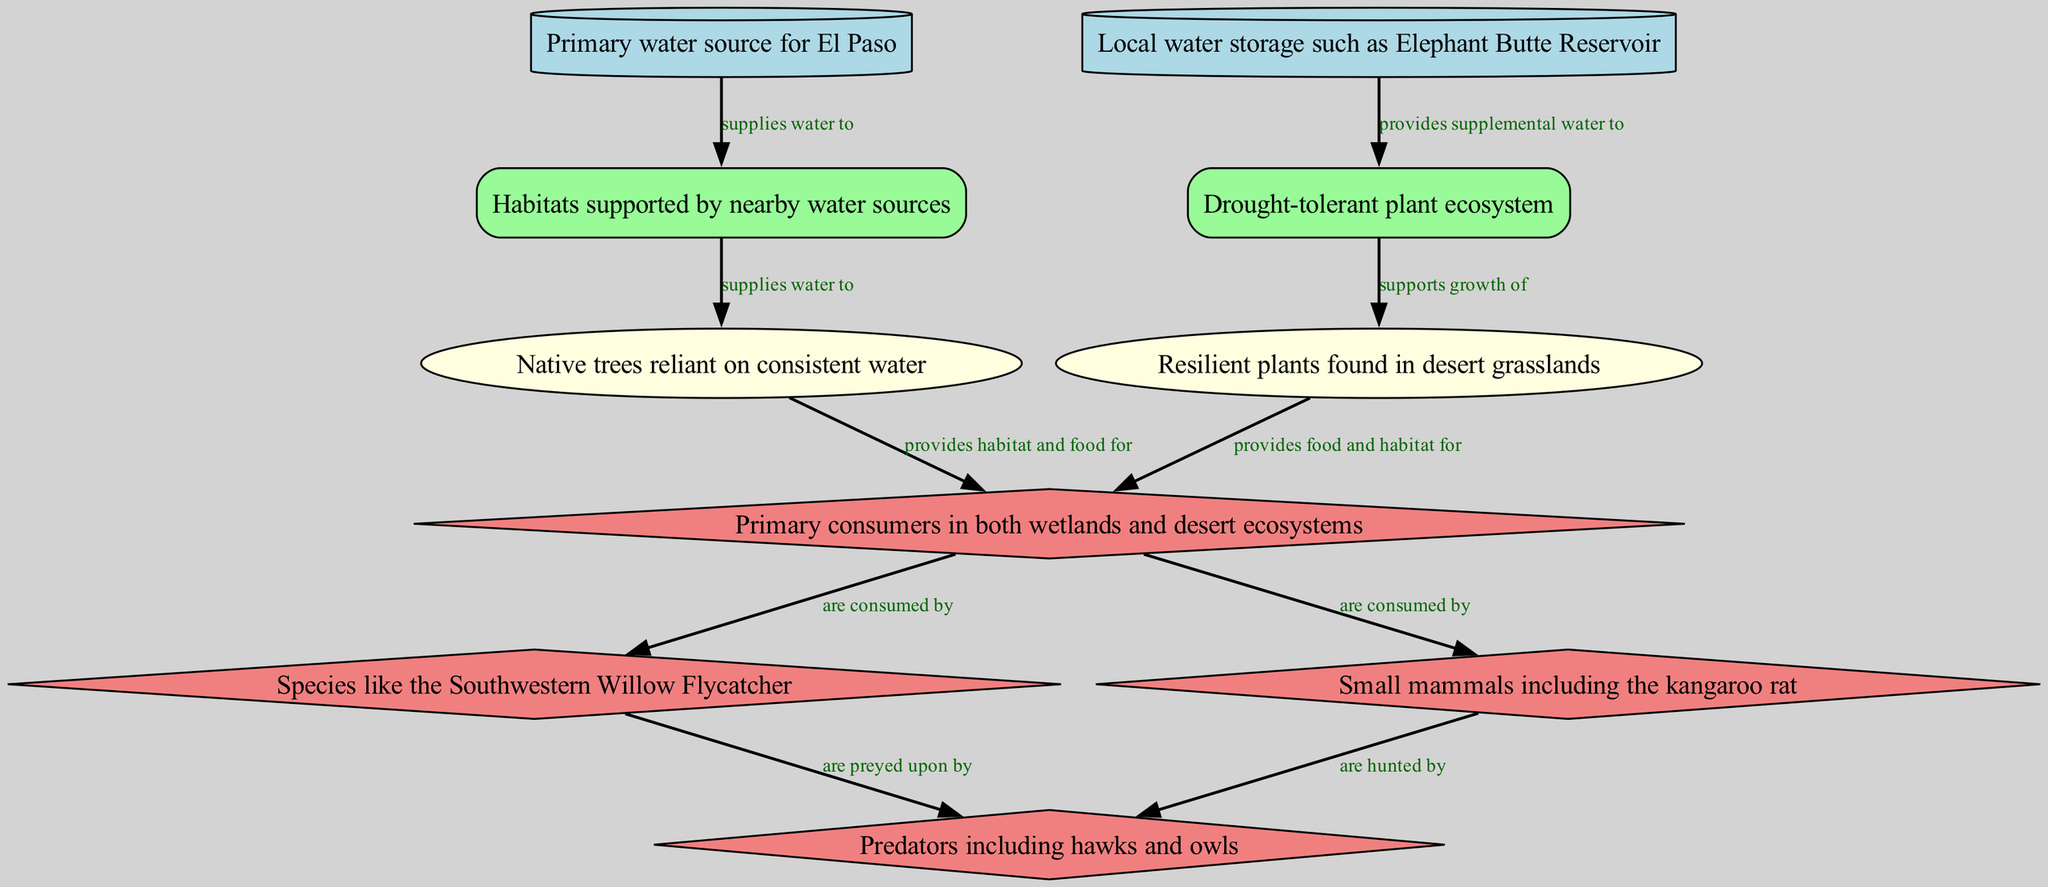What's the primary water source for El Paso? The diagram indicates that the main source of water is the Rio Grande, which is directly referenced as the "Primary water source for El Paso."
Answer: Rio Grande How many ecosystems are represented in the diagram? The diagram labels two ecosystems: Wetlands and Desert Grasslands. Therefore, the total count of ecosystems is two.
Answer: 2 What does the Rio Grande supply water to? According to the connections depicted in the diagram, the Rio Grande supplies water to Wetlands, establishing a direct relationship.
Answer: Wetlands Which flora is reliant on consistent water as shown in the diagram? The diagram specifies Cottonwood Trees as the flora that relies on a consistent water supply, highlighted under the flora section.
Answer: Cottonwood Trees What is the relationship between Yucca Plants and Insects? The diagram indicates that Yucca Plants provide food and habitat for Insects, establishing a direct ecological relationship.
Answer: provides food and habitat for How many different types of fauna are shown in the diagram? The diagram outlines three distinct types of fauna: Insects, Birds, and Rodents, leading to a total count of three types.
Answer: 3 What type of ecosystem is supported by the reservoirs? The diagram shows that the reservoirs provide supplemental water to Desert Grasslands, indicating that this is the ecosystem supported by them.
Answer: Desert Grasslands Which birds are highlighted as being preyed upon according to the diagram? The diagram indicates that Prey Birds are preyed upon by Birds, establishing a predatory relationship.
Answer: Birds What role do the Insects play in the food chain? In the diagram, Insects are shown to be consumed by both Birds and Rodents, indicating their role as primary consumers in the food chain.
Answer: are consumed by 